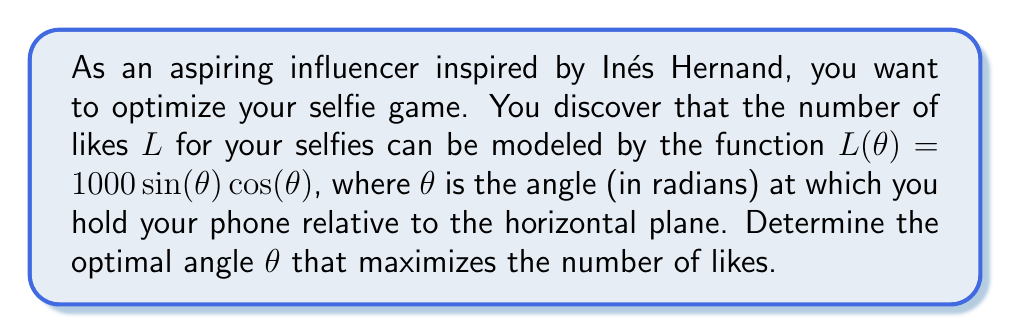Show me your answer to this math problem. To find the optimal angle that maximizes the number of likes, we need to follow these steps:

1) The given function is $L(\theta) = 1000 \sin(\theta) \cos(\theta)$

2) To find the maximum, we need to find the derivative of $L(\theta)$ and set it equal to zero:

   $$\frac{dL}{d\theta} = 1000 [\cos^2(\theta) - \sin^2(\theta)]$$

3) Set this equal to zero:

   $$1000 [\cos^2(\theta) - \sin^2(\theta)] = 0$$

4) Simplify:

   $$\cos^2(\theta) - \sin^2(\theta) = 0$$

5) Recall the trigonometric identity $\cos(2\theta) = \cos^2(\theta) - \sin^2(\theta)$

6) Therefore, our equation becomes:

   $$\cos(2\theta) = 0$$

7) Solve for $\theta$:

   $$2\theta = \frac{\pi}{2} + \pi n, \text{ where } n \text{ is an integer}$$

   $$\theta = \frac{\pi}{4} + \frac{\pi n}{2}$$

8) The smallest positive solution is when $n = 0$:

   $$\theta = \frac{\pi}{4} \text{ radians}$$

9) To confirm this is a maximum (not a minimum), we can check the second derivative:

   $$\frac{d^2L}{d\theta^2} = -2000 \sin(\theta) \cos(\theta)$$

   At $\theta = \frac{\pi}{4}$, this is negative, confirming a maximum.

10) Convert to degrees: $\frac{\pi}{4}$ radians = 45°
Answer: 45° 